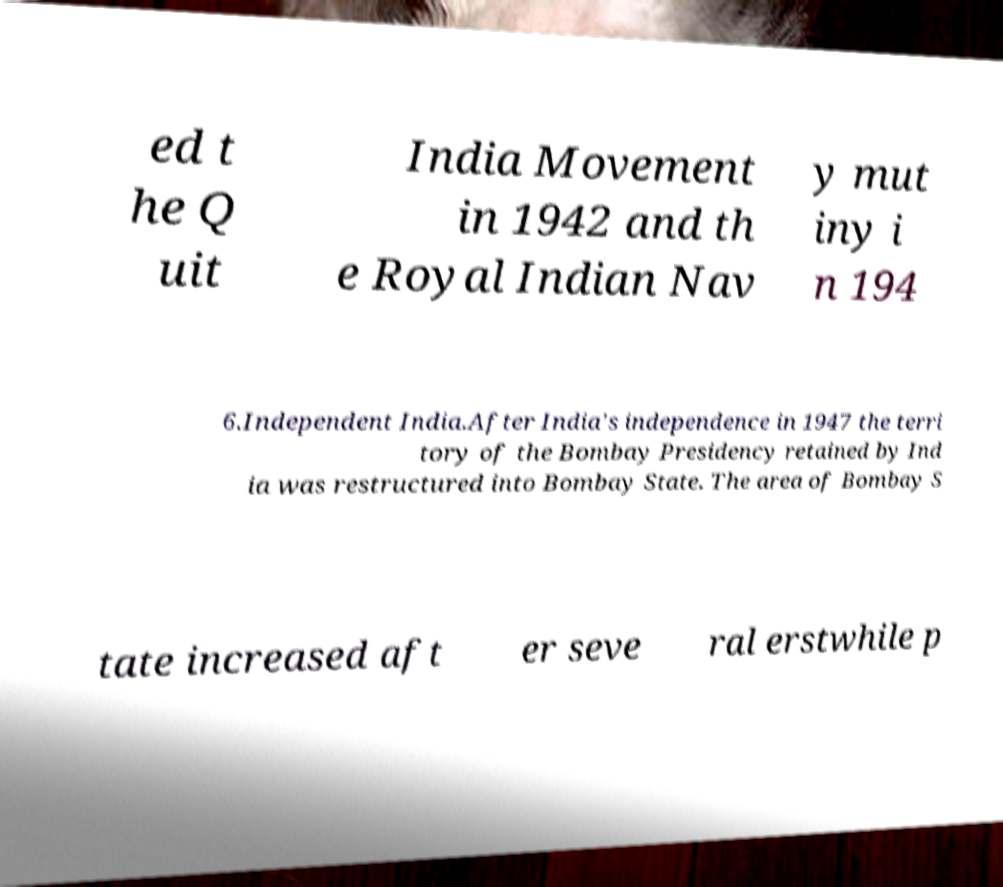I need the written content from this picture converted into text. Can you do that? ed t he Q uit India Movement in 1942 and th e Royal Indian Nav y mut iny i n 194 6.Independent India.After India's independence in 1947 the terri tory of the Bombay Presidency retained by Ind ia was restructured into Bombay State. The area of Bombay S tate increased aft er seve ral erstwhile p 